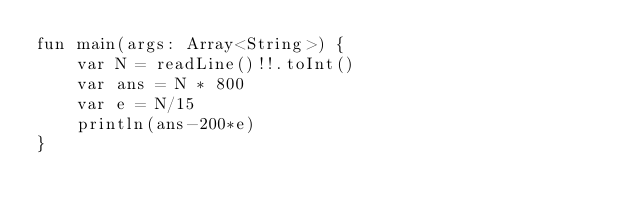Convert code to text. <code><loc_0><loc_0><loc_500><loc_500><_Kotlin_>fun main(args: Array<String>) {
    var N = readLine()!!.toInt()
    var ans = N * 800
    var e = N/15
    println(ans-200*e)
}
</code> 